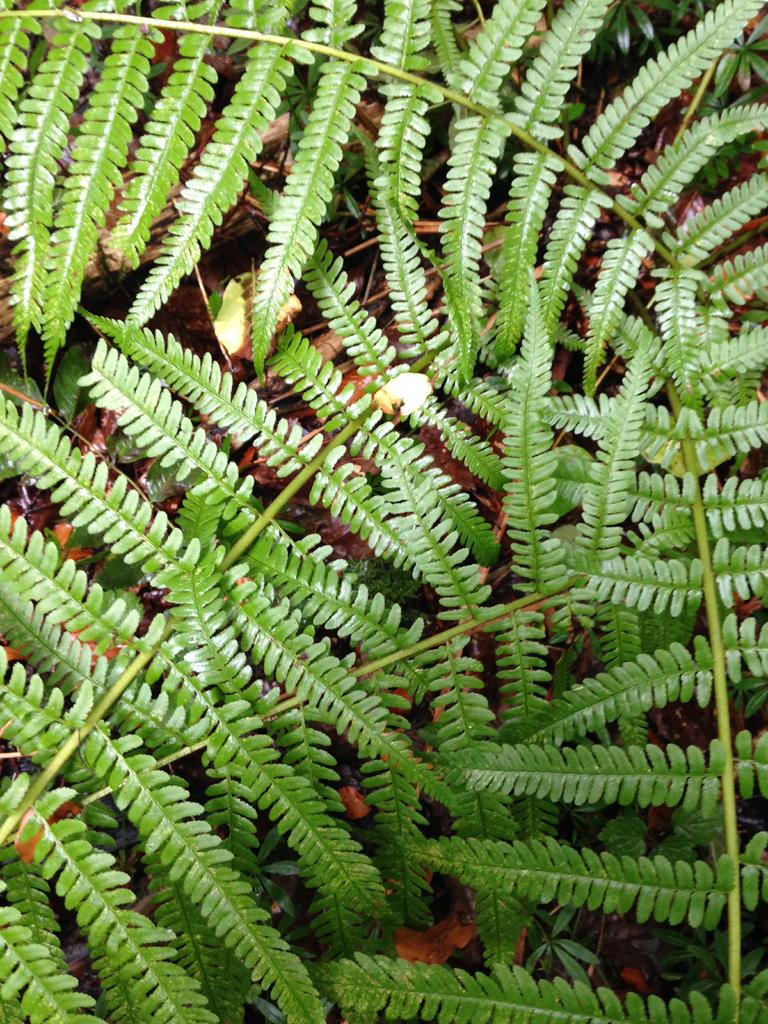What type of living organisms can be seen in the image? Plants can be seen in the image. What type of oil can be seen dripping from the hand on the rock in the image? There is no hand or rock present in the image, and therefore no oil can be seen dripping. 